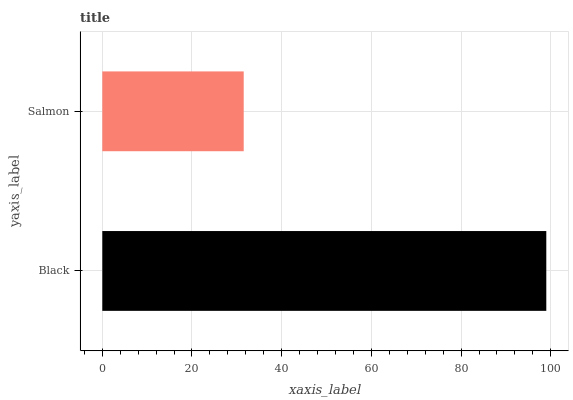Is Salmon the minimum?
Answer yes or no. Yes. Is Black the maximum?
Answer yes or no. Yes. Is Salmon the maximum?
Answer yes or no. No. Is Black greater than Salmon?
Answer yes or no. Yes. Is Salmon less than Black?
Answer yes or no. Yes. Is Salmon greater than Black?
Answer yes or no. No. Is Black less than Salmon?
Answer yes or no. No. Is Black the high median?
Answer yes or no. Yes. Is Salmon the low median?
Answer yes or no. Yes. Is Salmon the high median?
Answer yes or no. No. Is Black the low median?
Answer yes or no. No. 